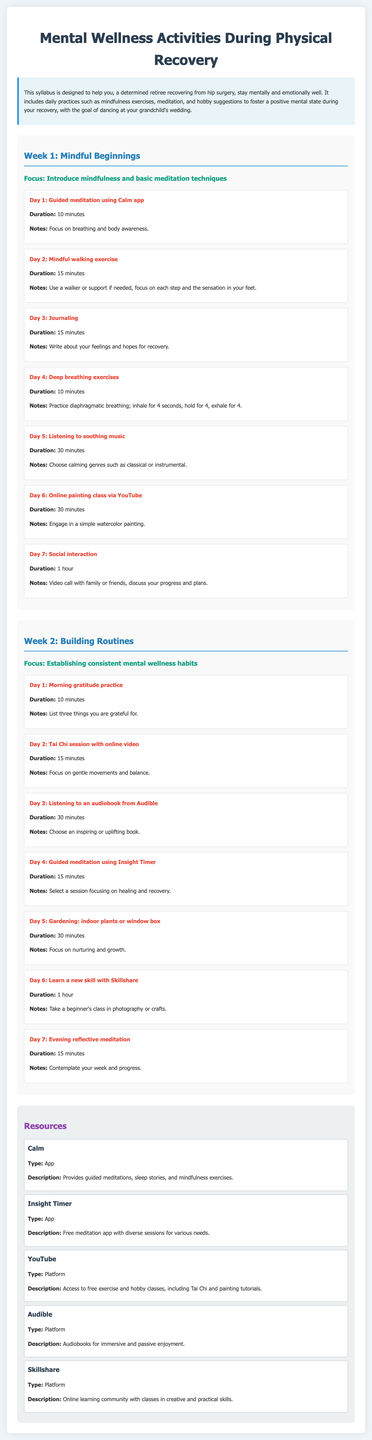What is the title of the syllabus? The title of the syllabus is provided in the document's header section.
Answer: Mental Wellness Activities During Physical Recovery What is the focus of Week 1? This focus is specified in the section titled "Week 1" and outlines the main theme for that week.
Answer: Introduce mindfulness and basic meditation techniques How long is the guided meditation on Day 1? The duration for Day 1's activity is stated in the description of that specific activity.
Answer: 10 minutes What activity involves social interaction? The document lists a specific day with a focus on connecting with others through a certain activity.
Answer: Video call with family or friends What is a suggested hobby in Week 2? The document provides examples of hobbies under different activities for Week 2's focus.
Answer: Gardening How many minutes are allocated for the evening reflective meditation on Day 7 of Week 2? The duration for this specific meditation is mentioned in the activity details for that day.
Answer: 15 minutes Which app is recommended for guided meditations? The syllabus includes resources and their descriptions, specifying apps for mental wellness techniques.
Answer: Calm What is the type of activity for Day 2 in Week 1? The type of activity can be identified from the daily suggestions listed in the syllabus.
Answer: Mindful walking exercise 